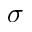Convert formula to latex. <formula><loc_0><loc_0><loc_500><loc_500>\sigma</formula> 